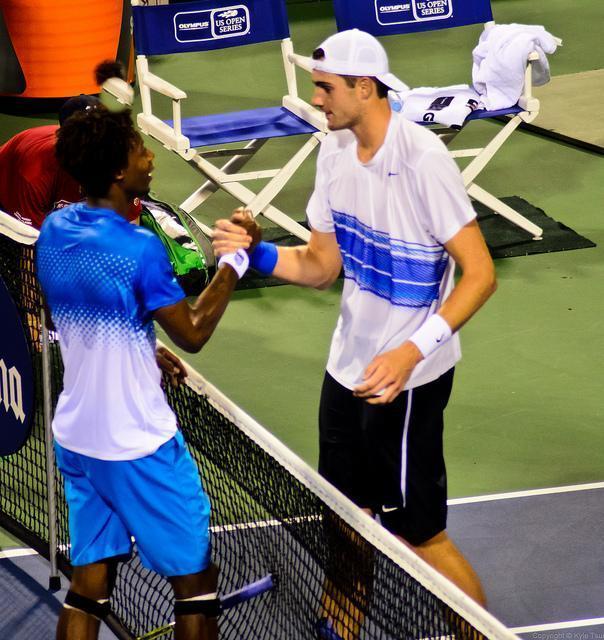How many chairs are there?
Give a very brief answer. 2. How many people are there?
Give a very brief answer. 3. How many sets of train tracks are there?
Give a very brief answer. 0. 